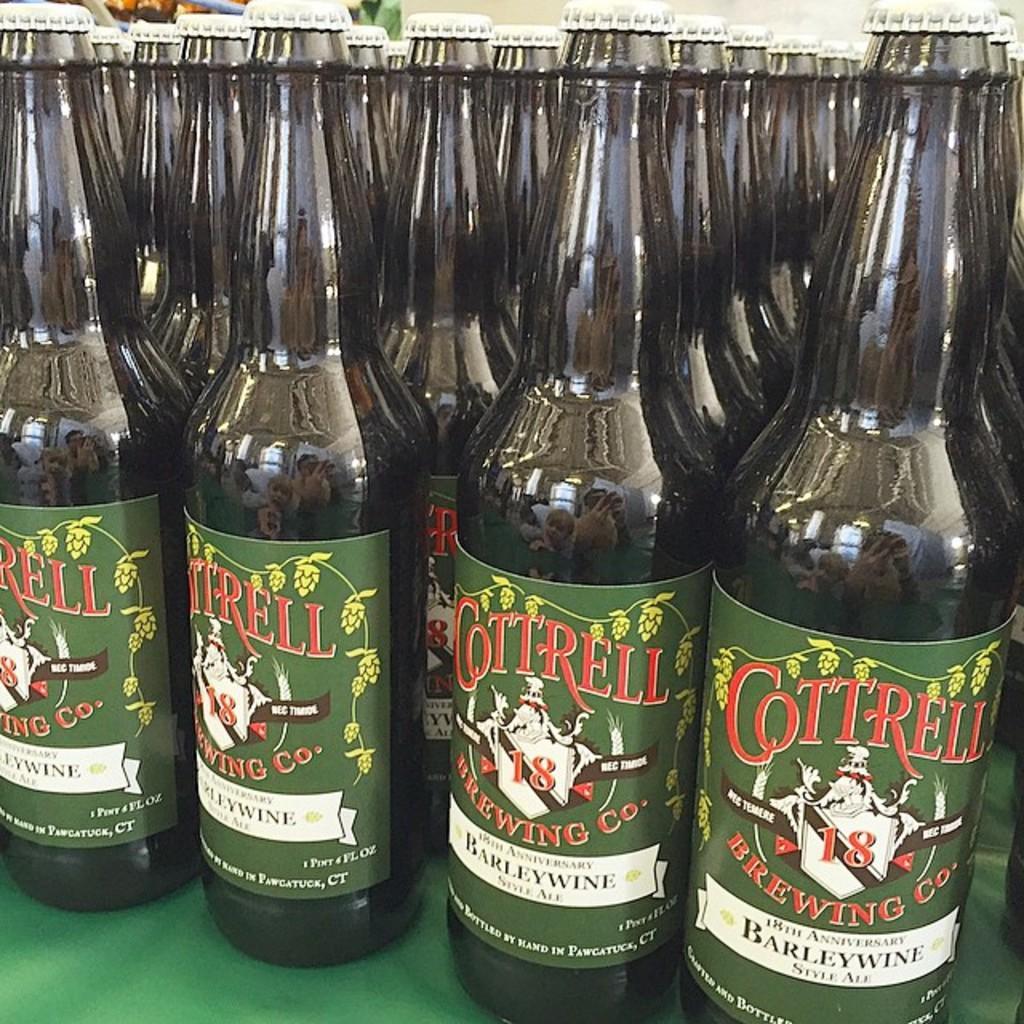In one or two sentences, can you explain what this image depicts? In this picture we can see bottles with stickers to it and this are placed on a green color floor and they are in a line. 